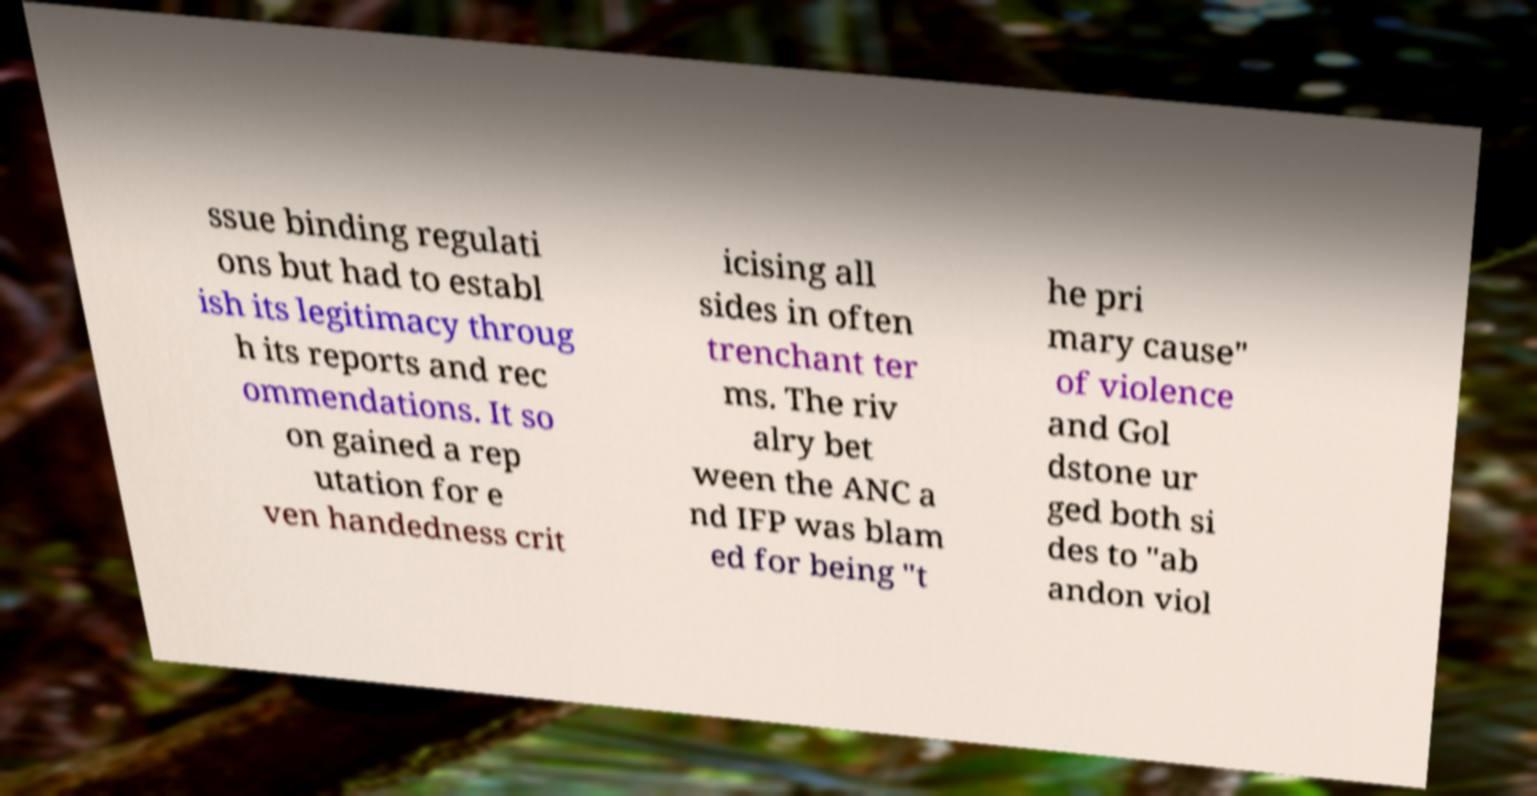What messages or text are displayed in this image? I need them in a readable, typed format. ssue binding regulati ons but had to establ ish its legitimacy throug h its reports and rec ommendations. It so on gained a rep utation for e ven handedness crit icising all sides in often trenchant ter ms. The riv alry bet ween the ANC a nd IFP was blam ed for being "t he pri mary cause" of violence and Gol dstone ur ged both si des to "ab andon viol 